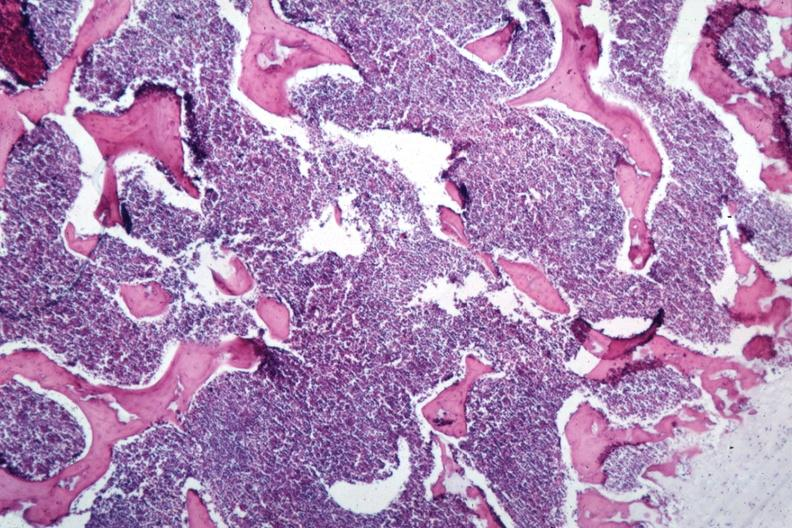what is present?
Answer the question using a single word or phrase. Hematologic 